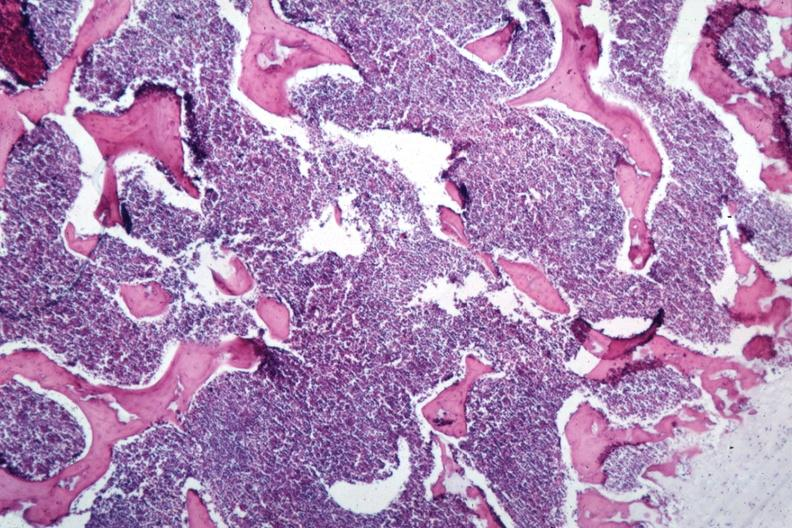what is present?
Answer the question using a single word or phrase. Hematologic 